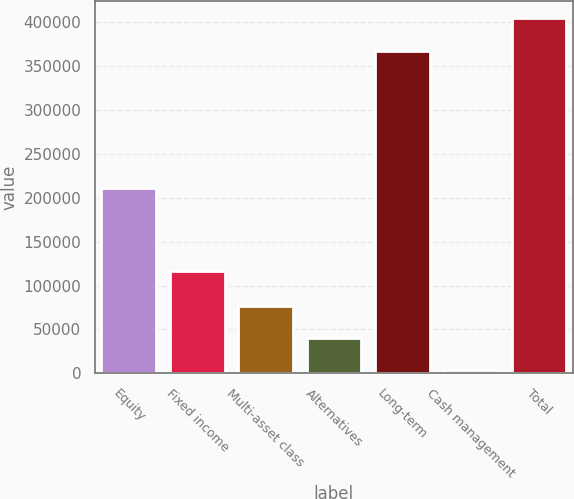Convert chart to OTSL. <chart><loc_0><loc_0><loc_500><loc_500><bar_chart><fcel>Equity<fcel>Fixed income<fcel>Multi-asset class<fcel>Alternatives<fcel>Long-term<fcel>Cash management<fcel>Total<nl><fcel>211594<fcel>117033<fcel>77157<fcel>40414<fcel>367430<fcel>3671<fcel>404173<nl></chart> 